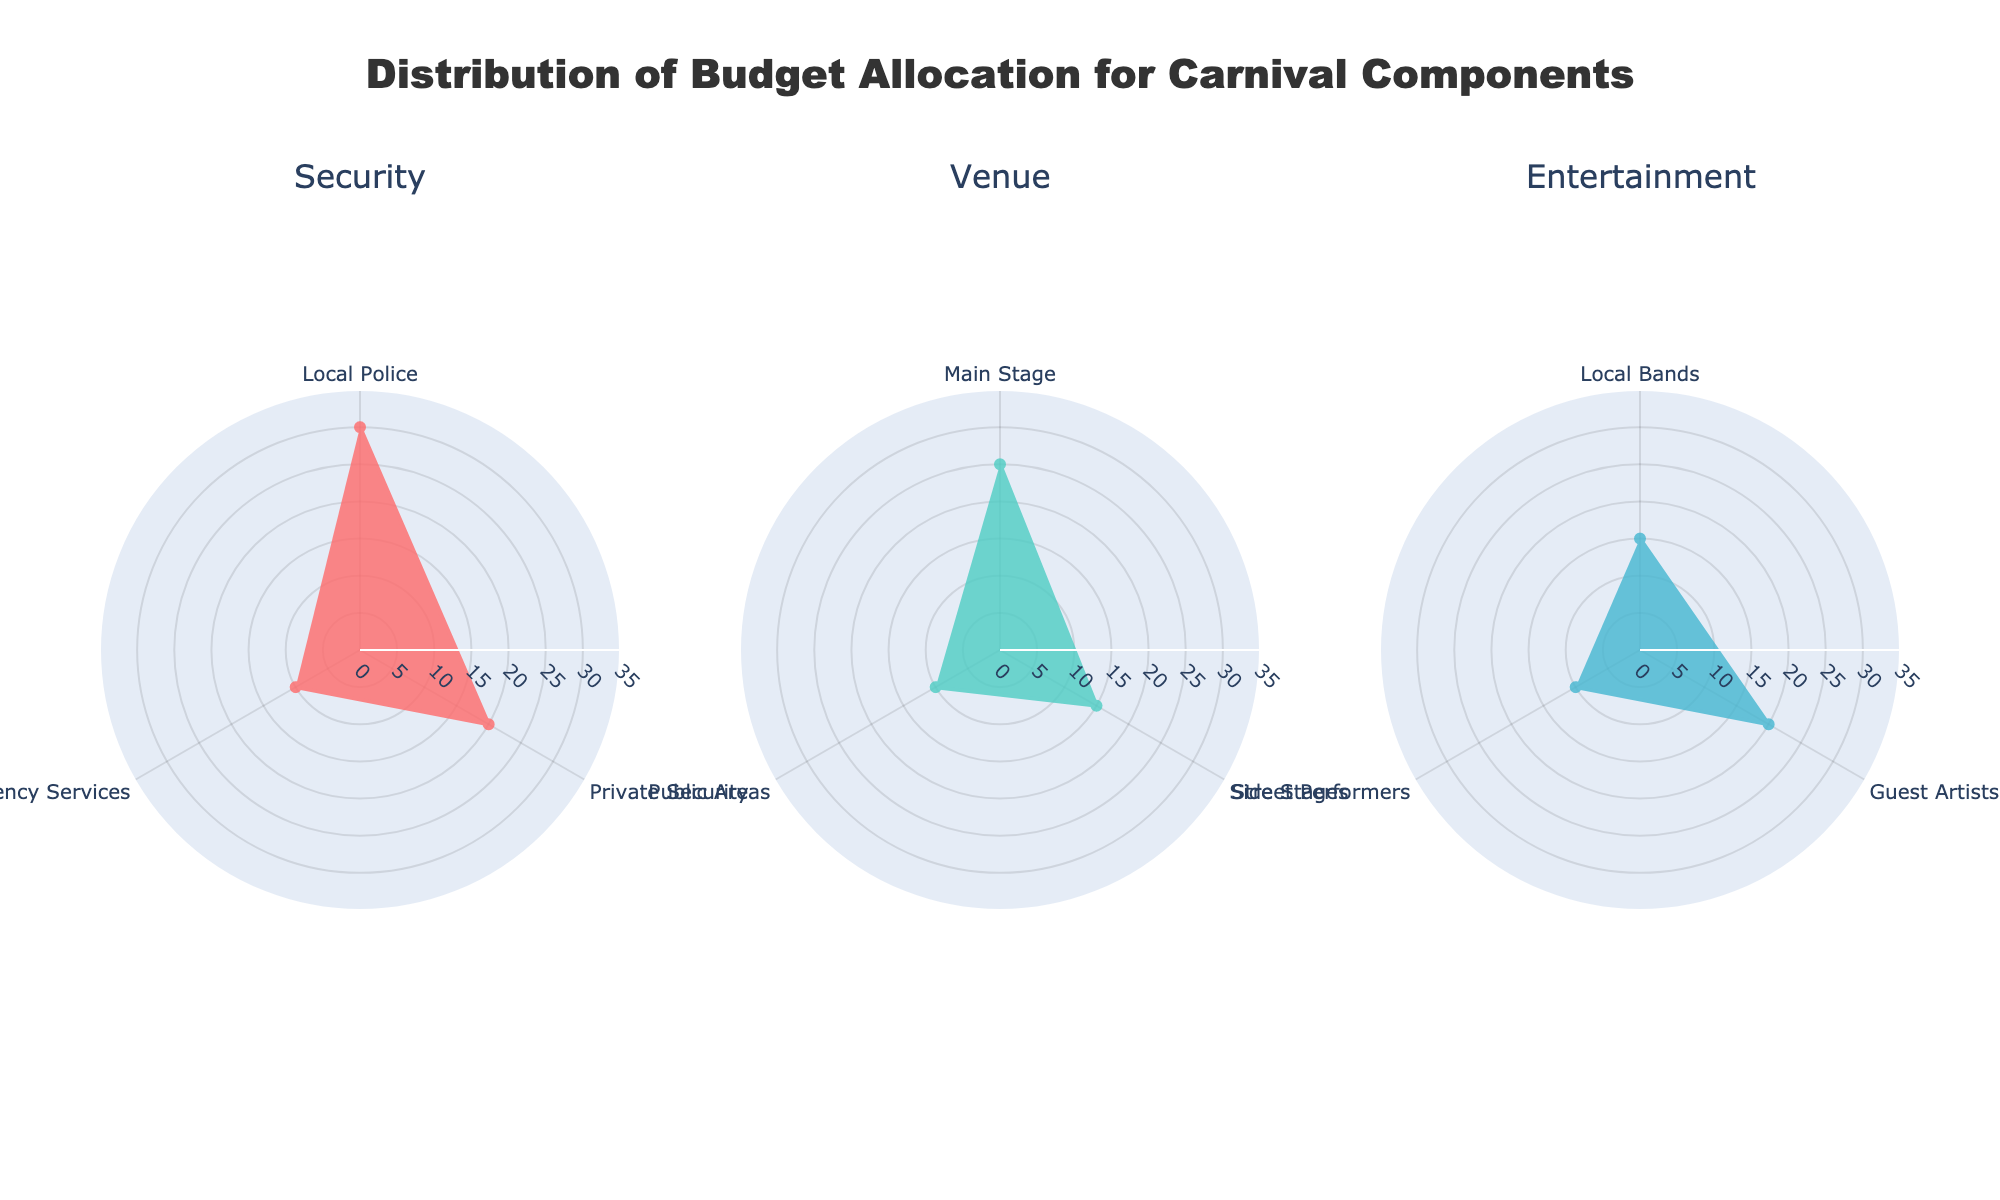What is the title of the chart? The title is clearly stated at the top of the figure, summarizing what the charts represent.
Answer: Distribution of Budget Allocation for Carnival Components How many polar charts are there in the figure? By counting the separate charts within the figure, you can see there are three distinct polar charts.
Answer: Three Which entity has the highest budget allocation in the Security component? Within the Security polar chart, the segment with the highest value is for Local Police.
Answer: Local Police How much more budget is allocated to Main Stage than to Public Areas in the Venue component? In the Venue polar chart, subtract the percentage of Public Areas (10%) from the percentage of Main Stage (25%) to find the difference.
Answer: 15% What is the combined budget allocation for Emergency Services and Private Security in the Security component? Adding the percentage allocation for Emergency Services (10%) and Private Security (20%) gives the total combined allocation.
Answer: 30% Which has a higher budget allocation: Guest Artists in Entertainment or Main Stage in Venue? Comparing the two percentages, Guest Artists have 20% while Main Stage has 25%, making Main Stage higher.
Answer: Main Stage What is the average budget allocation for the entities in the Entertainment component? Summing the percentages for Local Bands (15%), Guest Artists (20%), and Street Performers (10%) and then dividing by 3 gives the average.
Answer: 15% Which component has the lowest single budget allocation entity? By checking the smallest value in each polar chart, the smallest single allocation is for Public Areas in the Venue component with 10%.
Answer: Venue How much more budget is allocated to Local Bands compared to Street Performers in the Entertainment component? Subtract the percentage of Street Performers (10%) from the percentage of Local Bands (15%) to find the difference.
Answer: 5% What is the highest value on the radial axis of each polar chart? The radial axis for each polar chart has a range that tops out at 35, as indicated by the axis settings in the plot.
Answer: 35 